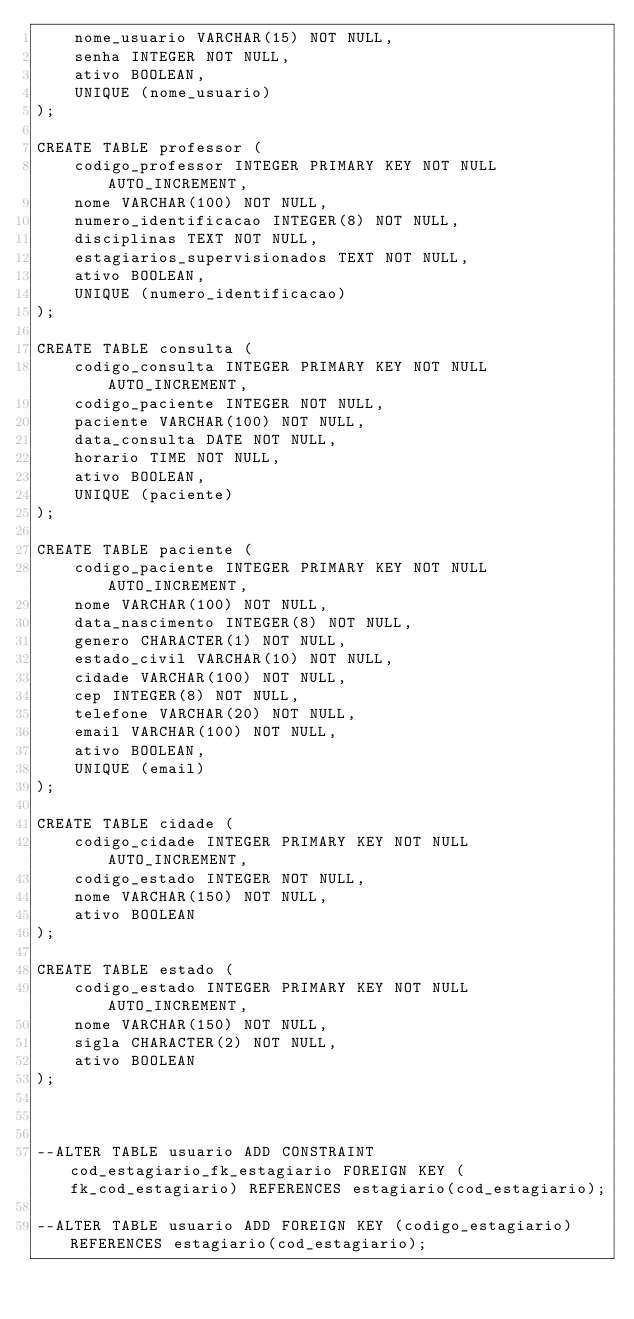<code> <loc_0><loc_0><loc_500><loc_500><_SQL_>    nome_usuario VARCHAR(15) NOT NULL,
    senha INTEGER NOT NULL,
    ativo BOOLEAN,
    UNIQUE (nome_usuario)
);

CREATE TABLE professor (
    codigo_professor INTEGER PRIMARY KEY NOT NULL AUTO_INCREMENT,
    nome VARCHAR(100) NOT NULL,
    numero_identificacao INTEGER(8) NOT NULL,
    disciplinas TEXT NOT NULL,
    estagiarios_supervisionados TEXT NOT NULL,
    ativo BOOLEAN,
    UNIQUE (numero_identificacao)
);

CREATE TABLE consulta (
    codigo_consulta INTEGER PRIMARY KEY NOT NULL AUTO_INCREMENT,
    codigo_paciente INTEGER NOT NULL,
    paciente VARCHAR(100) NOT NULL,
    data_consulta DATE NOT NULL,
    horario TIME NOT NULL,
    ativo BOOLEAN,
    UNIQUE (paciente)
);

CREATE TABLE paciente (
    codigo_paciente INTEGER PRIMARY KEY NOT NULL AUTO_INCREMENT,
    nome VARCHAR(100) NOT NULL,
    data_nascimento INTEGER(8) NOT NULL,
    genero CHARACTER(1) NOT NULL,
    estado_civil VARCHAR(10) NOT NULL,
    cidade VARCHAR(100) NOT NULL,
    cep INTEGER(8) NOT NULL,
    telefone VARCHAR(20) NOT NULL,
    email VARCHAR(100) NOT NULL,
    ativo BOOLEAN,
    UNIQUE (email)
);

CREATE TABLE cidade (
    codigo_cidade INTEGER PRIMARY KEY NOT NULL AUTO_INCREMENT,
    codigo_estado INTEGER NOT NULL,
    nome VARCHAR(150) NOT NULL,
    ativo BOOLEAN
);

CREATE TABLE estado (
    codigo_estado INTEGER PRIMARY KEY NOT NULL AUTO_INCREMENT,
    nome VARCHAR(150) NOT NULL,
    sigla CHARACTER(2) NOT NULL,
    ativo BOOLEAN
);



--ALTER TABLE usuario ADD CONSTRAINT cod_estagiario_fk_estagiario FOREIGN KEY (fk_cod_estagiario) REFERENCES estagiario(cod_estagiario);

--ALTER TABLE usuario ADD FOREIGN KEY (codigo_estagiario) REFERENCES estagiario(cod_estagiario);









</code> 